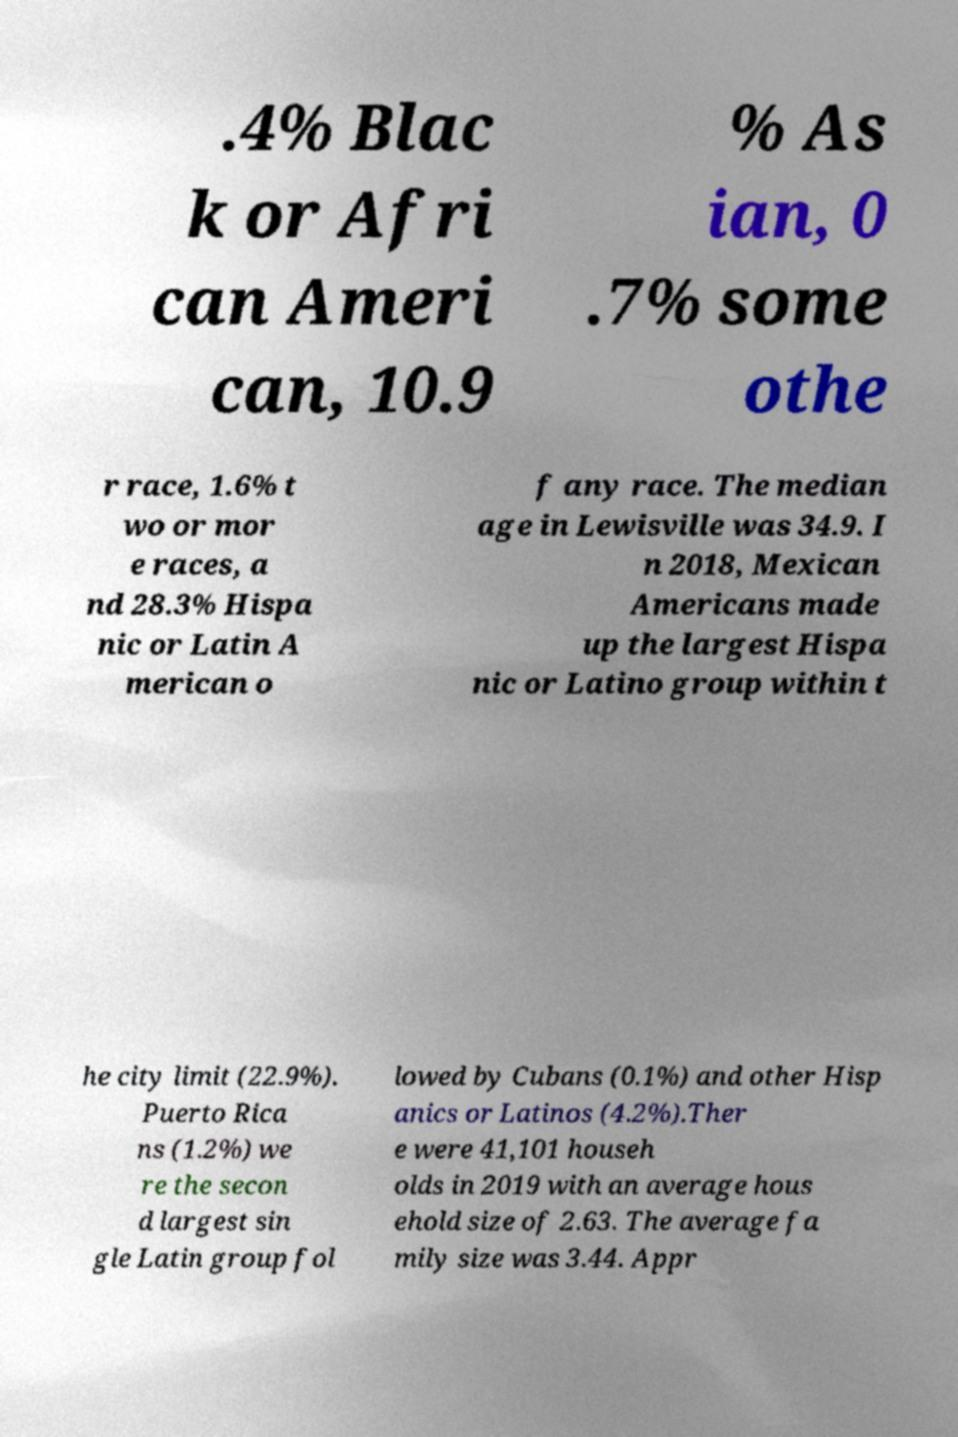For documentation purposes, I need the text within this image transcribed. Could you provide that? .4% Blac k or Afri can Ameri can, 10.9 % As ian, 0 .7% some othe r race, 1.6% t wo or mor e races, a nd 28.3% Hispa nic or Latin A merican o f any race. The median age in Lewisville was 34.9. I n 2018, Mexican Americans made up the largest Hispa nic or Latino group within t he city limit (22.9%). Puerto Rica ns (1.2%) we re the secon d largest sin gle Latin group fol lowed by Cubans (0.1%) and other Hisp anics or Latinos (4.2%).Ther e were 41,101 househ olds in 2019 with an average hous ehold size of 2.63. The average fa mily size was 3.44. Appr 